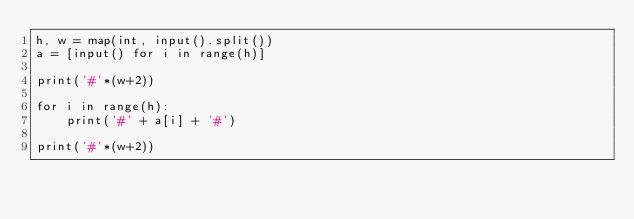<code> <loc_0><loc_0><loc_500><loc_500><_Python_>h, w = map(int, input().split())
a = [input() for i in range(h)]

print('#'*(w+2))

for i in range(h):
    print('#' + a[i] + '#')

print('#'*(w+2))
</code> 